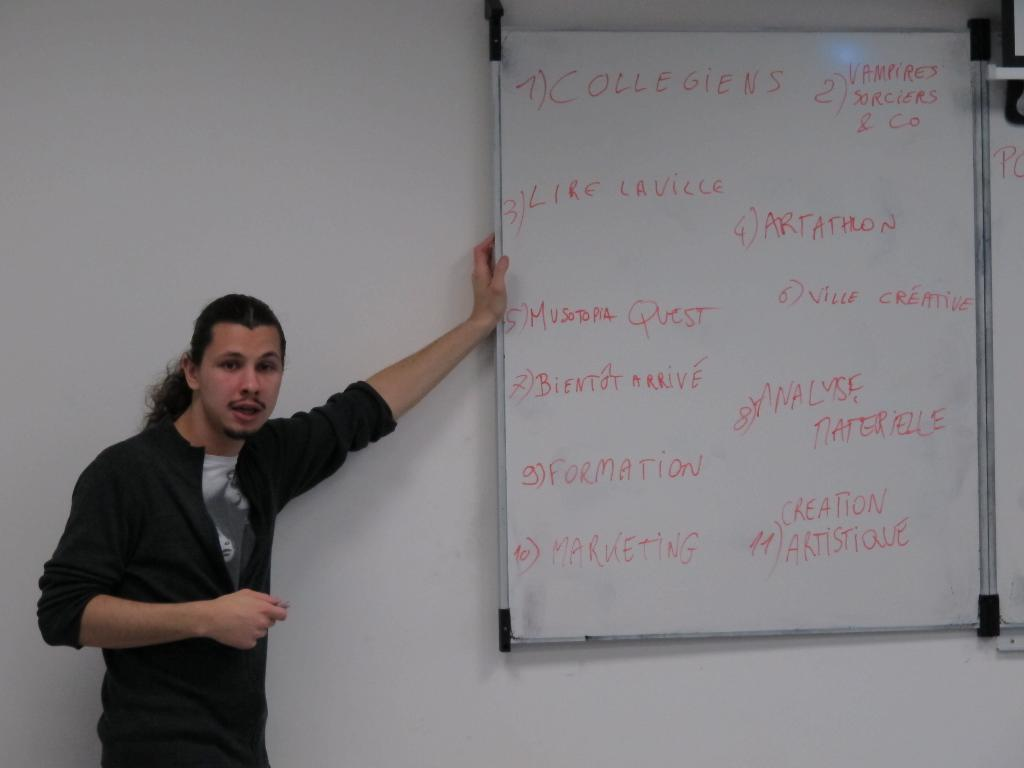What is the main subject of the image? There is a person standing in the image. Can you describe the person's attire? The person is wearing a black and gray color dress. What can be seen in the background of the image? There is a board attached to the wall in the background. What color is the wall in the image? The wall is in white color. What type of loaf is the person holding in the image? There is no loaf present in the image; the person is not holding anything. Is the person a beginner at something in the image? The facts provided do not give any information about the person's skill level or experience, so we cannot determine if they are a beginner at anything. 